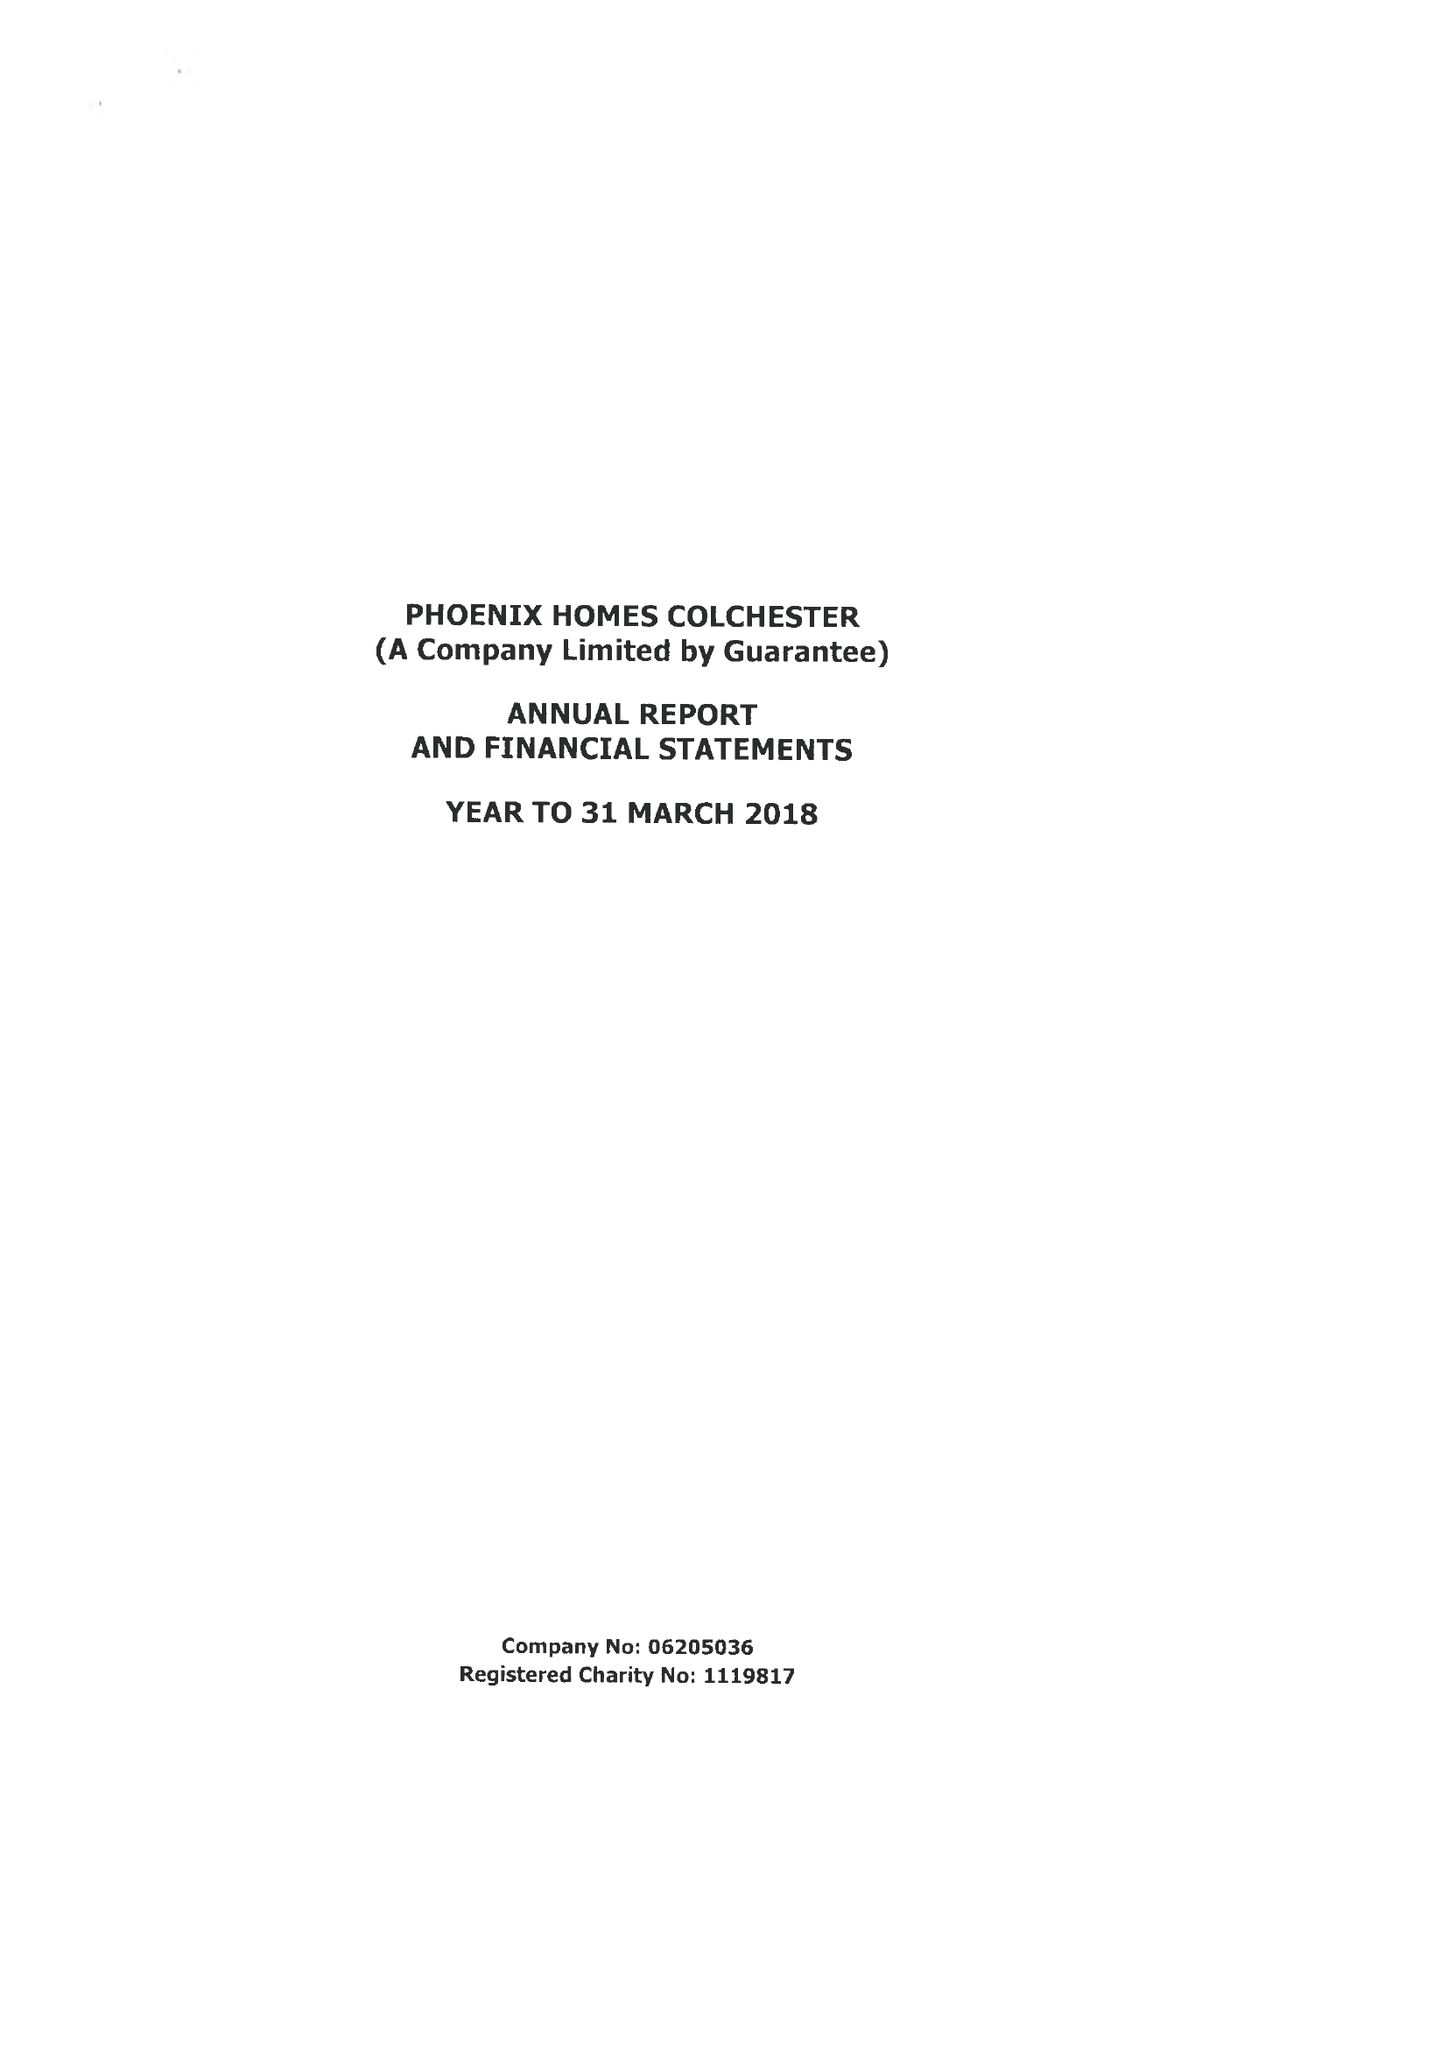What is the value for the spending_annually_in_british_pounds?
Answer the question using a single word or phrase. 361762.00 